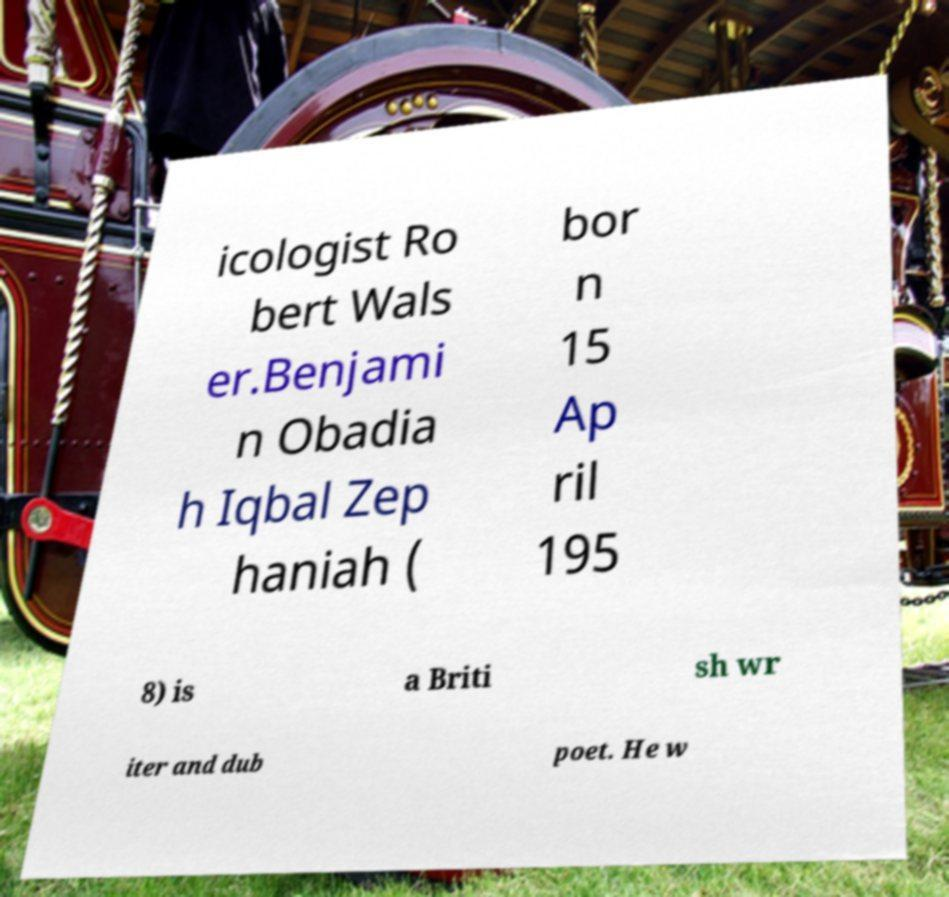Please read and relay the text visible in this image. What does it say? icologist Ro bert Wals er.Benjami n Obadia h Iqbal Zep haniah ( bor n 15 Ap ril 195 8) is a Briti sh wr iter and dub poet. He w 